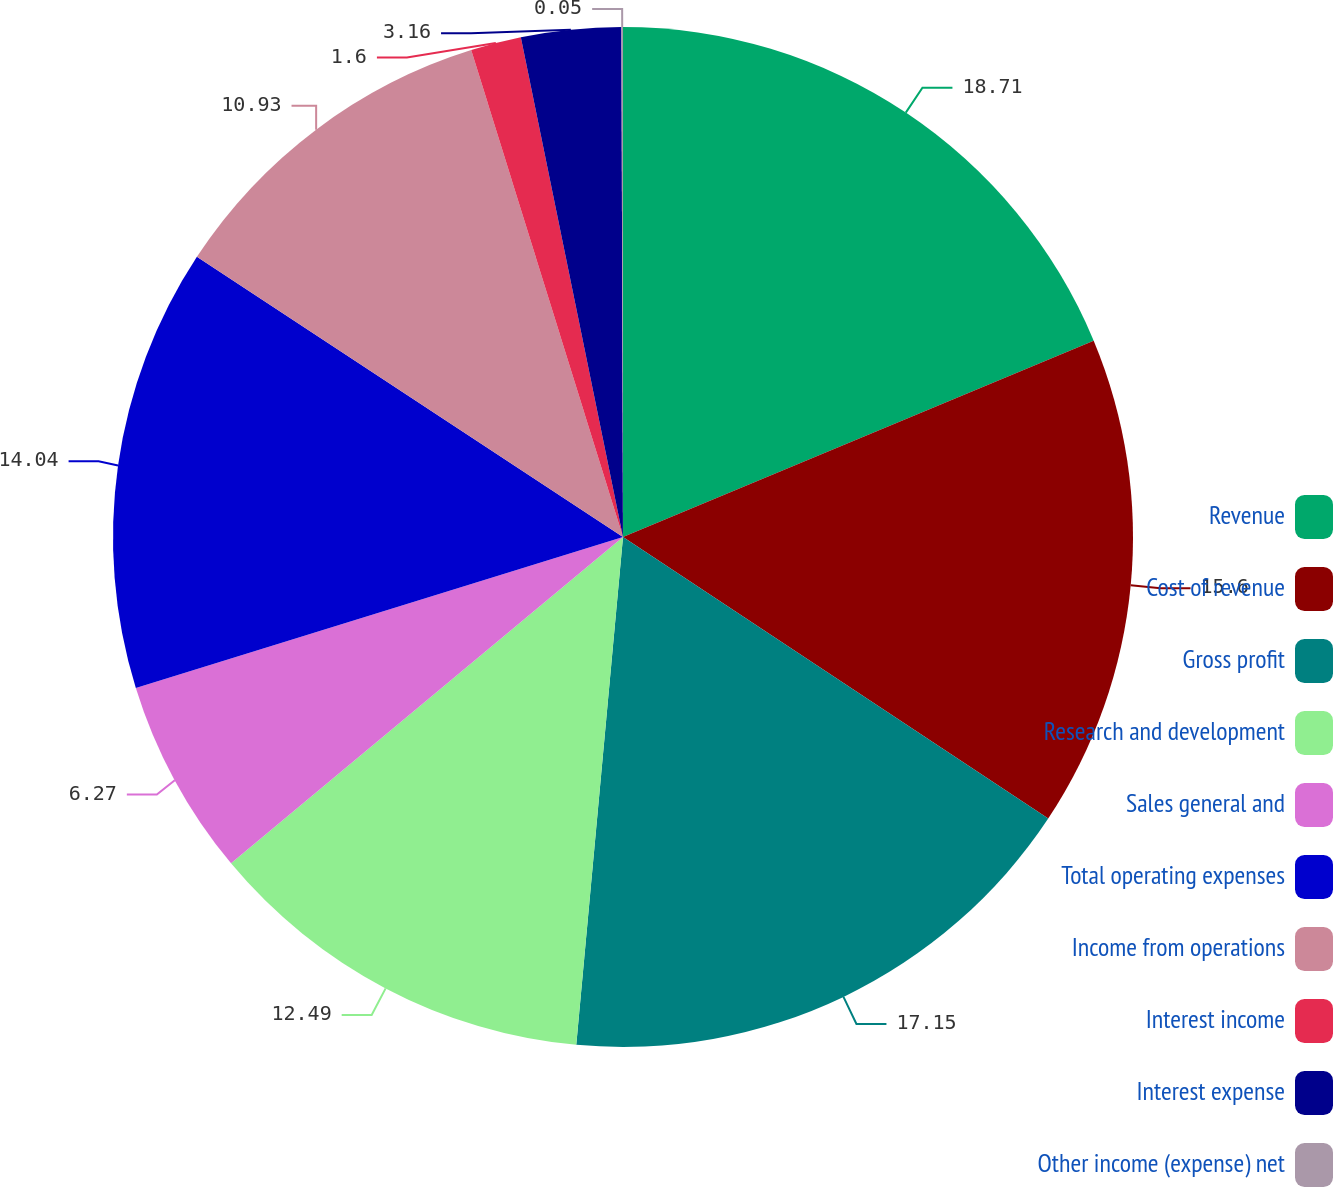<chart> <loc_0><loc_0><loc_500><loc_500><pie_chart><fcel>Revenue<fcel>Cost of revenue<fcel>Gross profit<fcel>Research and development<fcel>Sales general and<fcel>Total operating expenses<fcel>Income from operations<fcel>Interest income<fcel>Interest expense<fcel>Other income (expense) net<nl><fcel>18.71%<fcel>15.6%<fcel>17.15%<fcel>12.49%<fcel>6.27%<fcel>14.04%<fcel>10.93%<fcel>1.6%<fcel>3.16%<fcel>0.05%<nl></chart> 